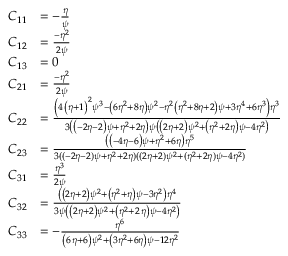<formula> <loc_0><loc_0><loc_500><loc_500>\begin{array} { r l } { C _ { 1 1 } } & { = - \frac { \eta } { \psi } } \\ { C _ { 1 2 } } & { = { \frac { - { \eta } ^ { 2 } } { 2 \psi } } } \\ { C _ { 1 3 } } & { = 0 } \\ { C _ { 2 1 } } & { = { \frac { - { \eta } ^ { 2 } } { 2 \psi } } } \\ { C _ { 2 2 } } & { = \frac { \left ( 4 \, \left ( \eta + 1 \right ) ^ { 2 } \psi ^ { 3 } - \left ( 6 \eta ^ { 2 } + 8 \eta \right ) \psi ^ { 2 } - \eta ^ { 2 } \left ( \eta ^ { 2 } + 8 \eta + 2 \right ) \psi + 3 \eta ^ { 4 } + 6 \eta ^ { 3 } \right ) { \eta } ^ { 3 } } { 3 \left ( \left ( - 2 \eta - 2 \right ) \psi + { \eta } ^ { 2 } + 2 \eta \right ) \psi \left ( \left ( 2 \eta + 2 \right ) \psi ^ { 2 } + \left ( { \eta } ^ { 2 } + 2 \eta \right ) \psi - 4 \eta ^ { 2 } \right ) } } \\ { C _ { 2 3 } } & { = \frac { \left ( \left ( - 4 \eta - 6 \right ) \psi + \eta ^ { 2 } + 6 \eta \right ) \eta ^ { 5 } } { 3 ( ( - 2 \eta - 2 ) \psi + \eta ^ { 2 } + 2 \eta ) ( ( 2 \eta + 2 ) \psi ^ { 2 } + ( \eta ^ { 2 } + 2 \eta ) \psi - 4 \eta ^ { 2 } ) } } \\ { C _ { 3 1 } } & { = { \frac { { \eta } ^ { 3 } } { 2 \psi } } } \\ { C _ { 3 2 } } & { = { \frac { \left ( \left ( 2 \eta + 2 \right ) \psi ^ { 2 } + \left ( { \eta } ^ { 2 } + \eta \right ) \psi - 3 \eta ^ { 2 } \right ) { \eta } ^ { 4 } } { 3 \psi \left ( \left ( 2 \eta + 2 \right ) \psi ^ { 2 } + \left ( { \eta } ^ { 2 } + 2 \, \eta \right ) \psi - 4 \eta ^ { 2 } \right ) } } } \\ { C _ { 3 3 } } & { = - { \frac { { \eta } ^ { 6 } } { \left ( 6 \, \eta + 6 \right ) \psi ^ { 2 } + \left ( 3 \eta ^ { 2 } + 6 \eta \right ) \psi - 1 2 \eta ^ { 2 } } } } \end{array}</formula> 